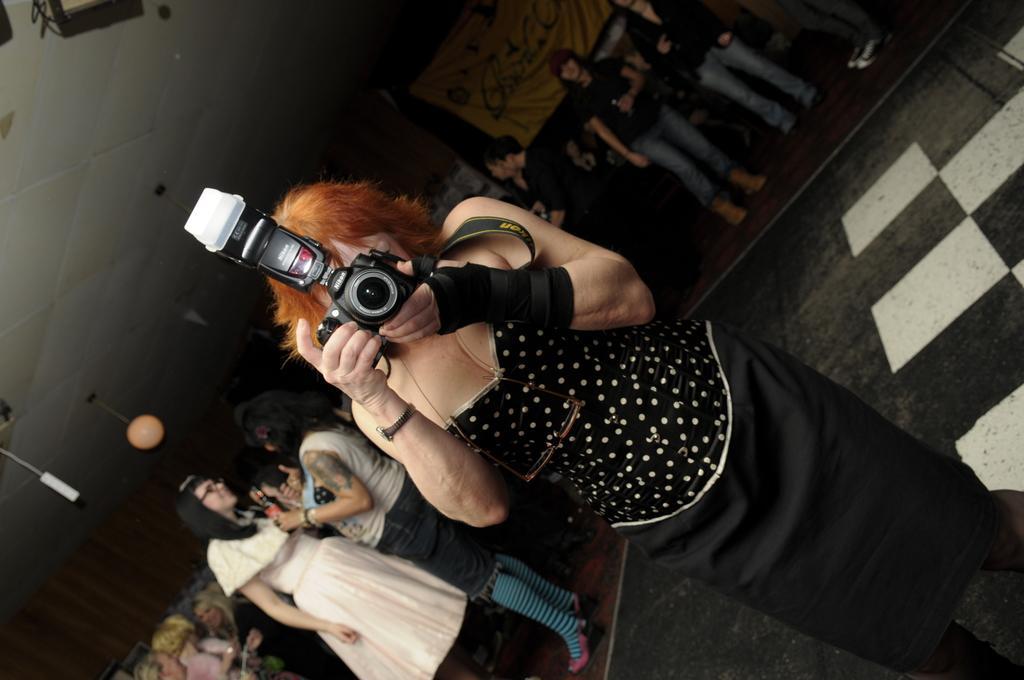In one or two sentences, can you explain what this image depicts? In this image I can see a person standing at the front wearing a black dress and holding a camera. There are other people behind her. There is a banner at the center back. 